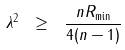Convert formula to latex. <formula><loc_0><loc_0><loc_500><loc_500>\lambda ^ { 2 } \ \geq \ \frac { n R _ { \min } } { 4 ( n - 1 ) }</formula> 